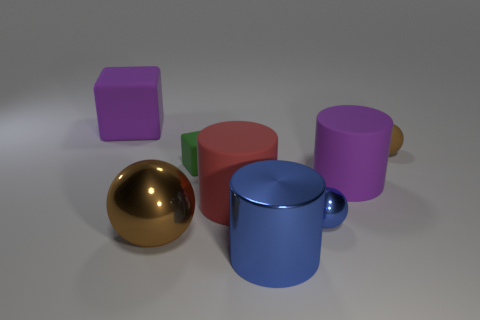What shape is the large shiny object that is the same color as the small metal ball?
Your answer should be very brief. Cylinder. What number of purple things are balls or rubber cubes?
Your response must be concise. 1. There is a small thing in front of the big red cylinder; does it have the same color as the large shiny cylinder?
Give a very brief answer. Yes. What shape is the brown object that is made of the same material as the red cylinder?
Keep it short and to the point. Sphere. There is a thing that is right of the small blue shiny object and in front of the green object; what is its color?
Ensure brevity in your answer.  Purple. There is a brown object that is to the right of the ball to the left of the big blue metal cylinder; how big is it?
Provide a succinct answer. Small. Is there a small rubber block that has the same color as the small matte sphere?
Give a very brief answer. No. Are there the same number of tiny brown rubber objects that are in front of the small blue shiny object and blue shiny balls?
Your answer should be very brief. No. What number of large metal objects are there?
Your response must be concise. 2. There is a small thing that is both behind the tiny metallic ball and right of the big metal cylinder; what is its shape?
Make the answer very short. Sphere. 